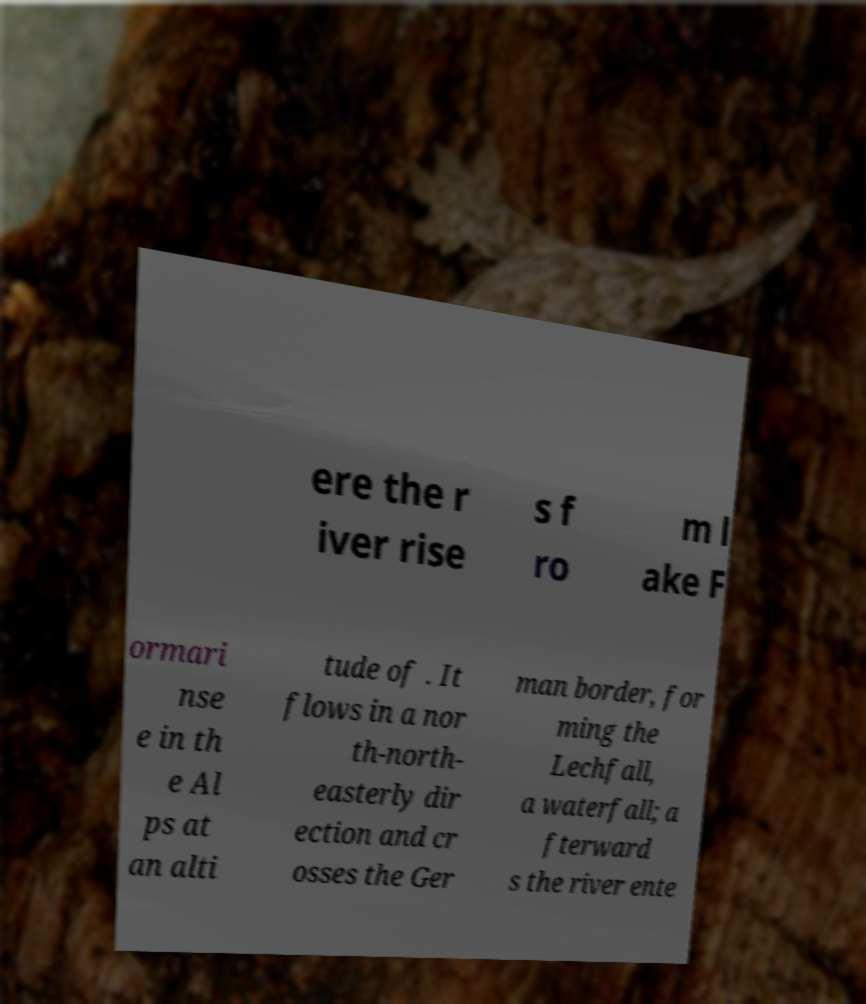Please identify and transcribe the text found in this image. ere the r iver rise s f ro m l ake F ormari nse e in th e Al ps at an alti tude of . It flows in a nor th-north- easterly dir ection and cr osses the Ger man border, for ming the Lechfall, a waterfall; a fterward s the river ente 